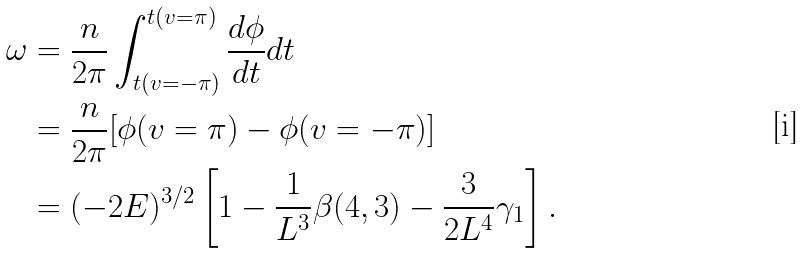<formula> <loc_0><loc_0><loc_500><loc_500>\omega & = \frac { n } { 2 \pi } \int _ { t ( v = - \pi ) } ^ { t ( v = \pi ) } \frac { d \phi } { d t } d t \\ & = \frac { n } { 2 \pi } [ \phi ( v = \pi ) - \phi ( v = - \pi ) ] \\ & = ( - 2 E ) ^ { 3 / 2 } \left [ 1 - \frac { 1 } { L ^ { 3 } } \beta ( 4 , 3 ) - \frac { 3 } { 2 L ^ { 4 } } \gamma _ { 1 } \right ] .</formula> 